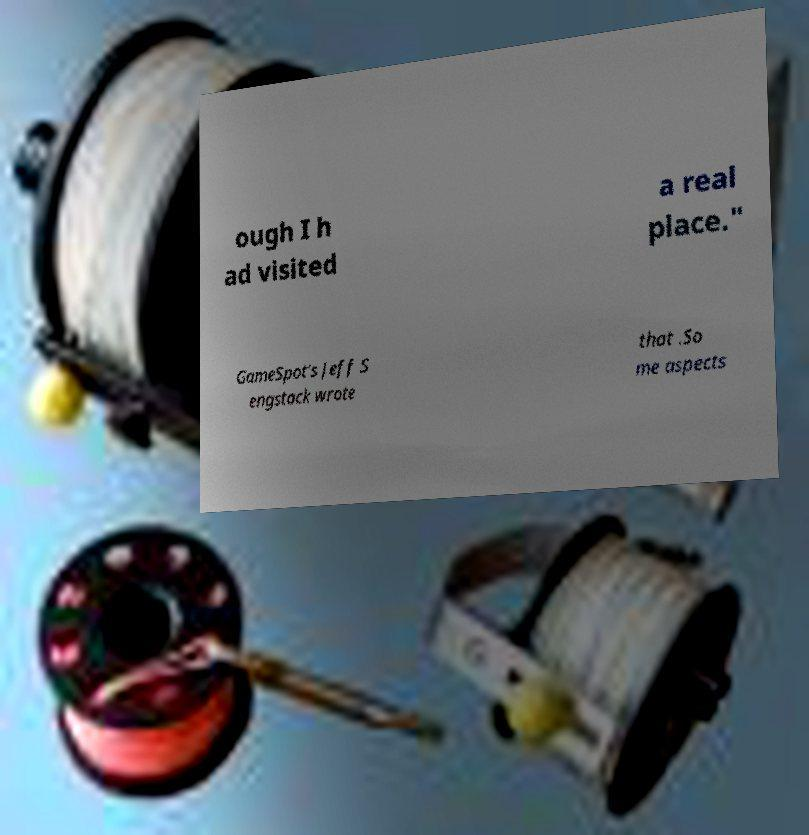For documentation purposes, I need the text within this image transcribed. Could you provide that? ough I h ad visited a real place." GameSpot's Jeff S engstack wrote that .So me aspects 